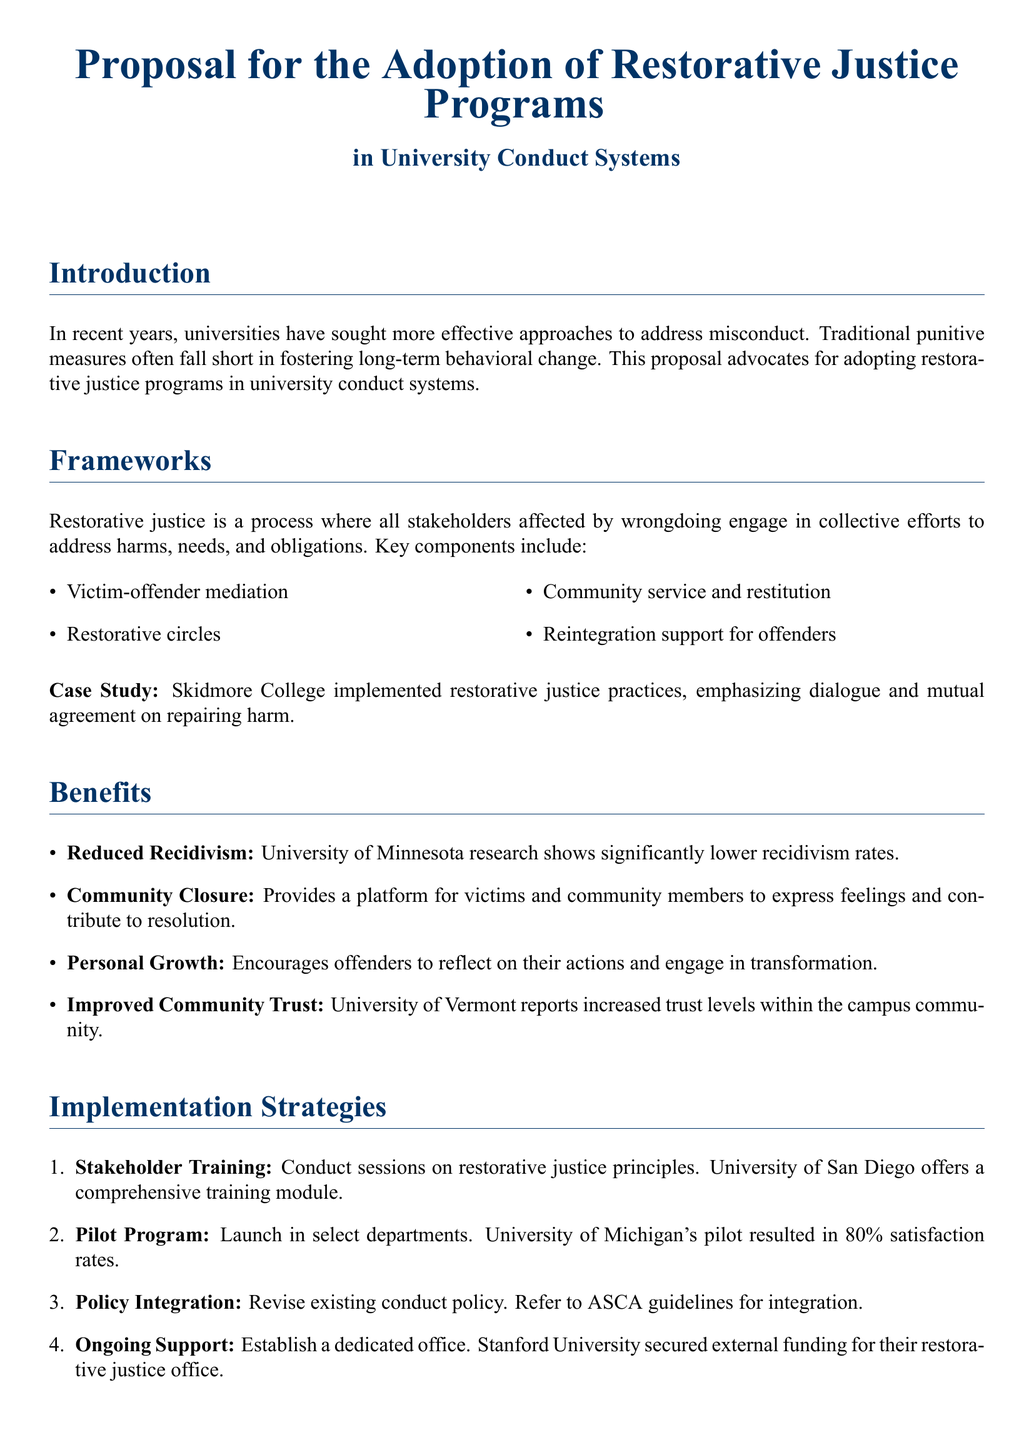what is the primary focus of the proposal? The proposal advocates for adopting restorative justice programs in university conduct systems.
Answer: restorative justice programs name one key component of restorative justice. The document lists several key components, including victim-offender mediation.
Answer: victim-offender mediation which university reported increased trust levels within the campus community? The document mentions that the University of Vermont reported increased trust levels.
Answer: University of Vermont what was the satisfaction rate of the pilot program at the University of Michigan? The pilot program at the University of Michigan resulted in 80% satisfaction rates.
Answer: 80% how many strategies for implementation are outlined in the proposal? The proposal lists four specific implementation strategies.
Answer: four what is one benefit of restorative justice mentioned in the document? One benefit highlighted is personal growth for offenders.
Answer: personal growth which college emphasized dialogue in its restorative justice practices? The document provides a case study of Skidmore College emphasizing dialogue.
Answer: Skidmore College what type of training is suggested for stakeholders? The document suggests conducting sessions on restorative justice principles for stakeholders.
Answer: training sessions 